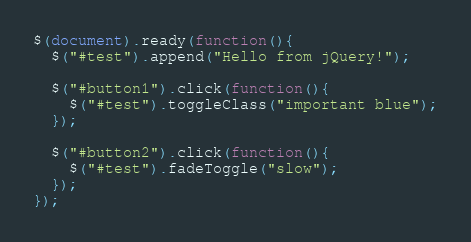Convert code to text. <code><loc_0><loc_0><loc_500><loc_500><_JavaScript_>$(document).ready(function(){
  $("#test").append("Hello from jQuery!");
  
  $("#button1").click(function(){
    $("#test").toggleClass("important blue");
  });
  
  $("#button2").click(function(){
    $("#test").fadeToggle("slow");
  });
});</code> 